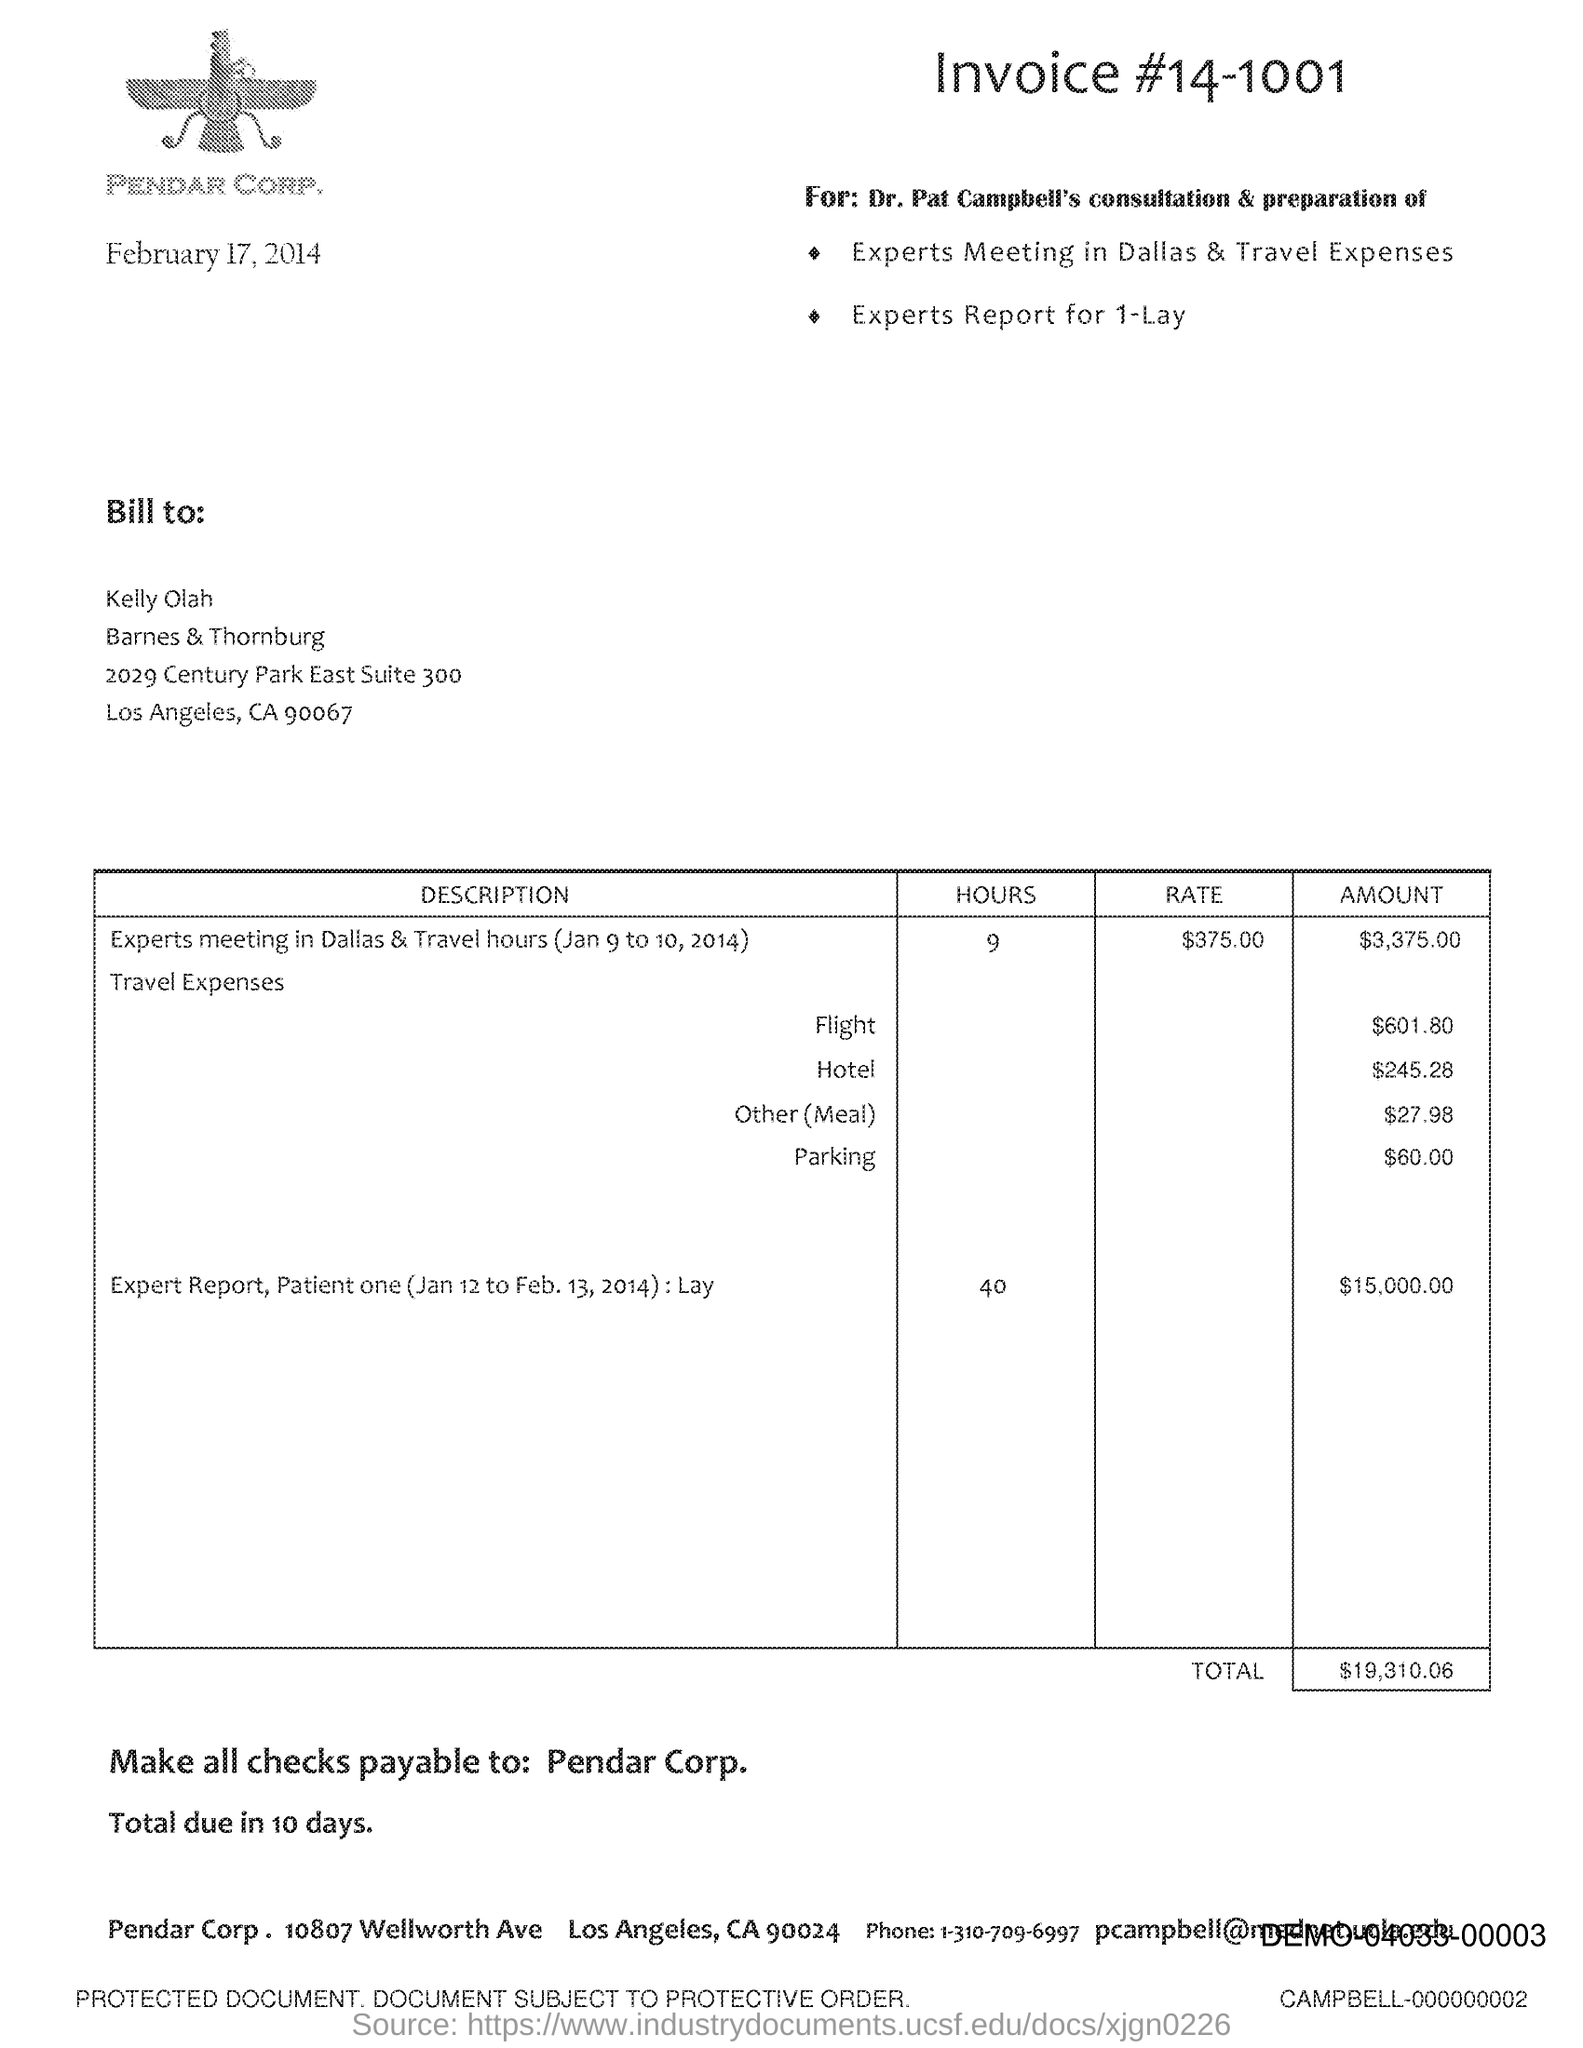What is invoice#?
Offer a terse response. 14-1001. What is the total?
Provide a short and direct response. $19,310.06. In which state is pendar corp. located?
Your answer should be compact. CA. What is the address of pendar corp?
Give a very brief answer. 10807 Wellworth Ave. 